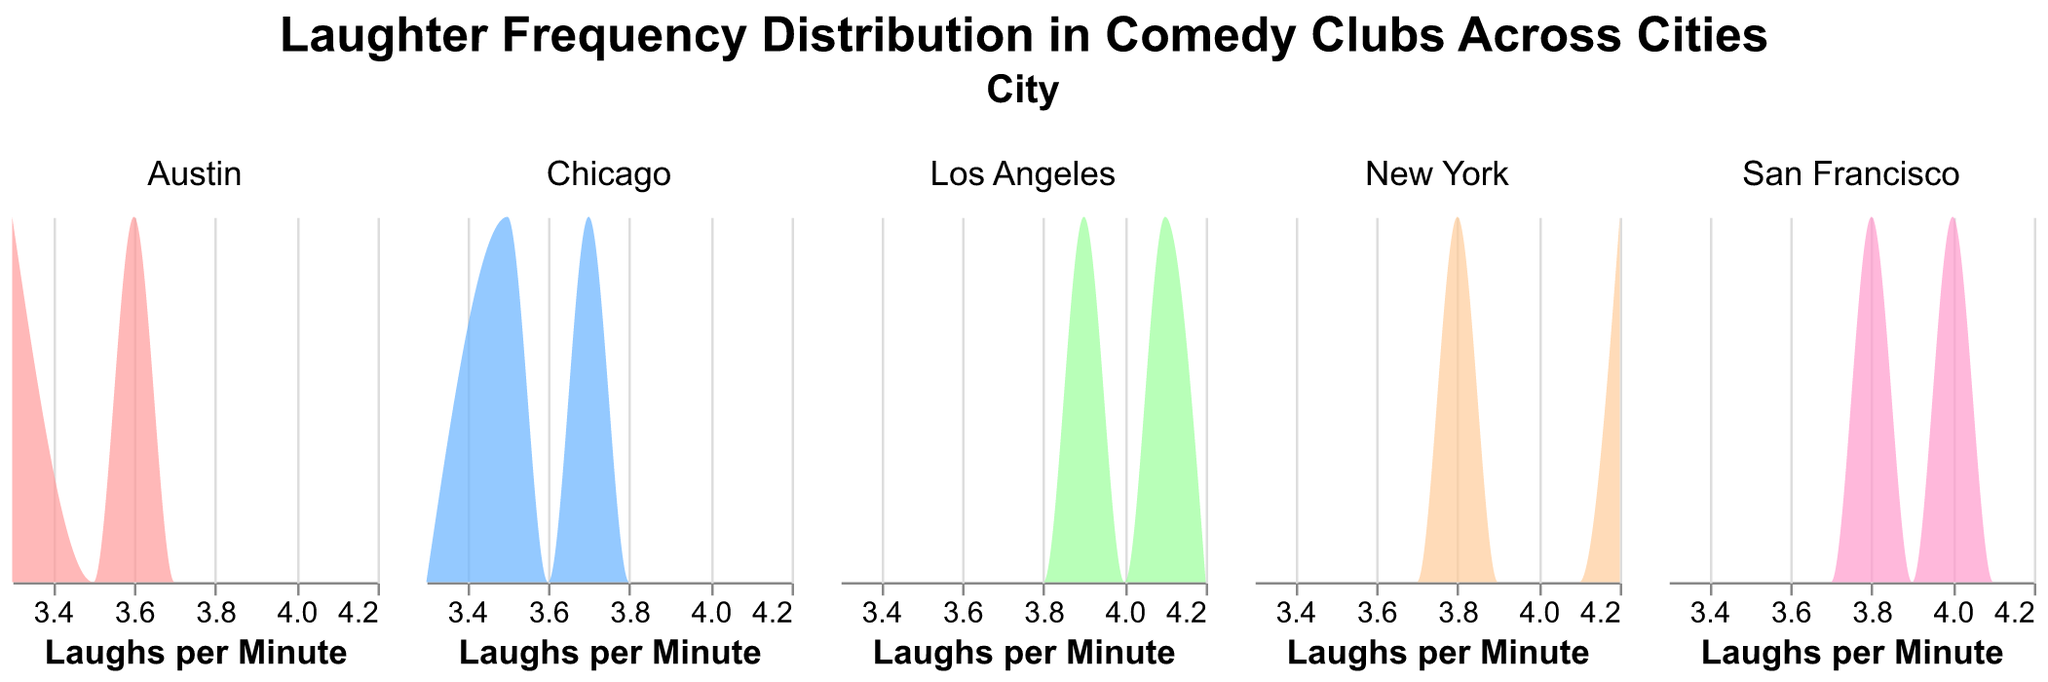What is the title of the figure? The title of the figure is displayed at the top, giving a summary of what the plot represents.
Answer: Laughter Frequency Distribution in Comedy Clubs Across Cities Which city shows the highest average laughter frequency among its comedy clubs? By comparing the average laughter frequencies of comedy clubs in each city, we see that New York's Comedy Cellar has the highest frequency at 4.2 laughs per minute.
Answer: New York Which cities have their comedy clubs with the lowest laughter frequency? The plot shows that Austin's Velveeta Room has the lowest laughter frequency at 3.3 laughs per minute.
Answer: Austin Which comedy club in Los Angeles has a higher laughter frequency, The Comedy Store or Hollywood Improv? Comparing the laughter frequencies of the two clubs in Los Angeles, The Comedy Store has a higher frequency at 4.1 compared to Hollywood Improv's 3.9.
Answer: The Comedy Store How many cities are represented in the figure? Each distinct subplot represents a city, which corresponds to the number of cities presented. There are 5 subplots.
Answer: 5 What is the average laughter frequency for comedy clubs in Chicago? Computed by adding the laughter frequencies of the two comedy clubs in Chicago (3.5 and 3.7) and dividing by 2. The average is (3.5 + 3.7) / 2 = 3.6.
Answer: 3.6 Which city has the most diversity in laughter frequencies among its comedy clubs? To determine diversity, we compare the range of laughter frequencies within each city. Los Angeles has clubs with laughter frequencies of 4.1 and 3.9, resulting in a range of 0.2, the largest among the others.
Answer: Los Angeles Which comedy club in San Francisco has a lower laughter frequency? Comparing the two comedy clubs in San Francisco, Cobb's Comedy Club at 4.0 and Punchline SF at 3.8, the latter has the lower frequency.
Answer: Punchline SF How do the laughter frequencies of Austin comedy clubs compare to those in San Francisco? Comparing average values, Austin's clubs average 3.6 and 3.3, while San Francisco's clubs average 4.0 and 3.8. The combined average for Austin is lower than San Francisco.
Answer: San Francisco is higher What is the color used to represent New York in the density plots? By observing the colors of the density plots in the “New York” subplot, we can identify it in one of the plots' legend. The color for New York is a specific shade of red.
Answer: Red 